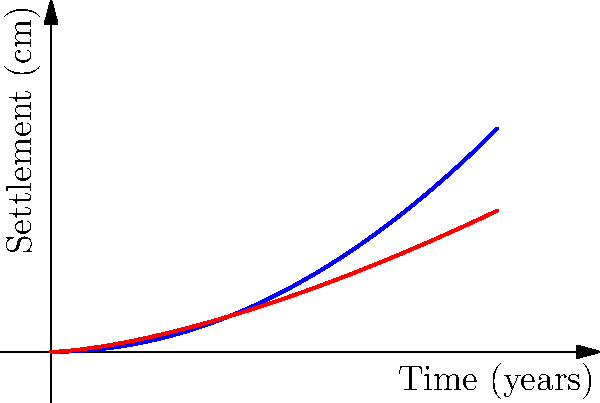As a pathologist studying unique medical cases, you often encounter situations where environmental factors play a role in patient health. In a recent case, you're investigating the potential health impacts on residents of two buildings with different foundation settlement patterns. The graph shows the settlement patterns of two multi-story buildings over time. Based on the settlement curves, which building is more likely to experience structural issues that could lead to health concerns for its residents, and why? To answer this question, we need to analyze the settlement patterns of both buildings:

1. Interpret the graph:
   - x-axis represents time in years
   - y-axis represents settlement in centimeters
   - Blue curve (Building A): follows a quadratic function $f(x) = 0.05x^2$
   - Red curve (Building B): follows a power function $g(x) = 0.1x^{1.5}$

2. Compare the settlement rates:
   - Building A: The settlement rate increases over time (curve becomes steeper)
   - Building B: The settlement rate decreases over time (curve flattens out)

3. Analyze long-term behavior:
   - At the 10-year mark, Building A settles more than Building B
   - The gap between the two curves widens as time progresses

4. Consider structural implications:
   - Accelerating settlement (Building A) is more concerning than decelerating settlement (Building B)
   - Faster and increasing settlement can lead to more structural stress and potential damage

5. Relate to health concerns:
   - Structural issues can cause cracks, water infiltration, and mold growth
   - Uneven settlement may lead to tilting, affecting elevators and other building systems
   - These factors can contribute to respiratory problems, allergies, and other health issues

6. Conclusion:
   Building A, with its accelerating settlement pattern, is more likely to experience structural issues that could lead to health concerns for its residents.
Answer: Building A, due to accelerating settlement pattern 